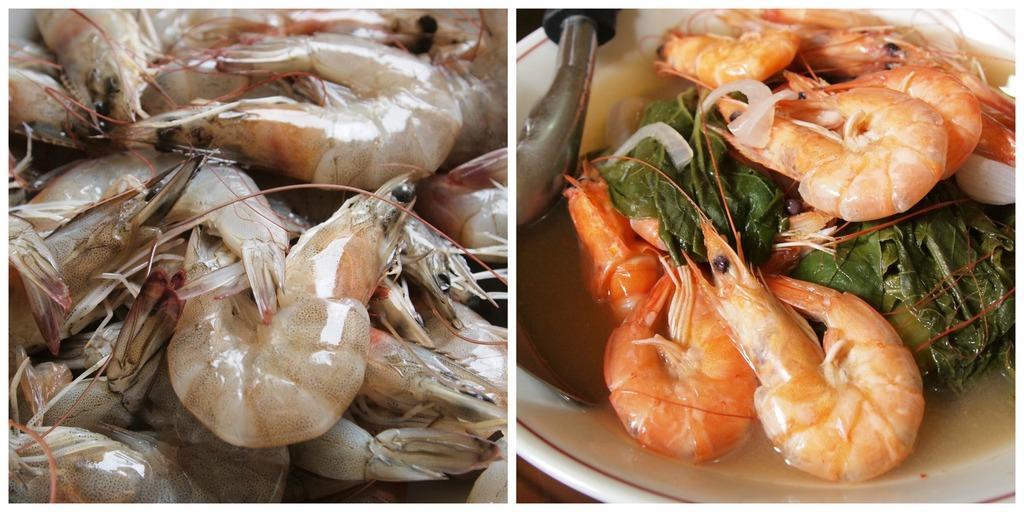Can you describe this image briefly? This image is a collage of prawns. 